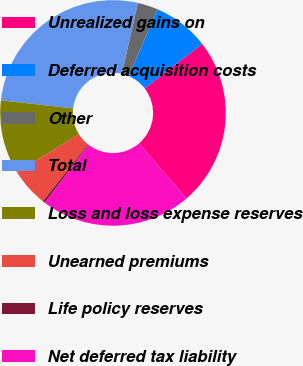Convert chart to OTSL. <chart><loc_0><loc_0><loc_500><loc_500><pie_chart><fcel>Unrealized gains on<fcel>Deferred acquisition costs<fcel>Other<fcel>Total<fcel>Loss and loss expense reserves<fcel>Unearned premiums<fcel>Life policy reserves<fcel>Net deferred tax liability<nl><fcel>24.19%<fcel>8.06%<fcel>2.92%<fcel>26.76%<fcel>10.63%<fcel>5.49%<fcel>0.35%<fcel>21.62%<nl></chart> 